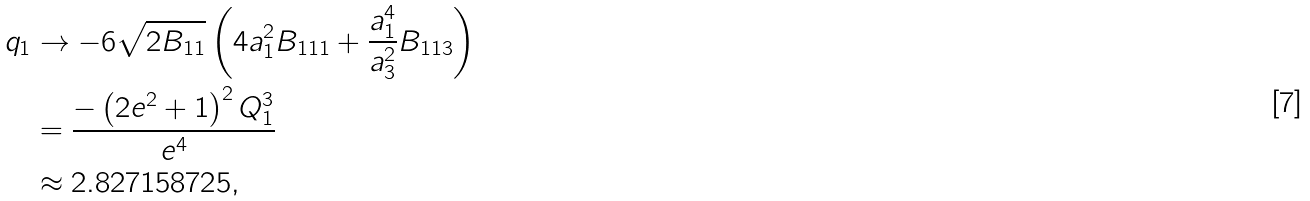<formula> <loc_0><loc_0><loc_500><loc_500>q _ { 1 } & \to - 6 \sqrt { 2 B _ { 1 1 } } \left ( 4 a _ { 1 } ^ { 2 } B _ { 1 1 1 } + \frac { a _ { 1 } ^ { 4 } } { a _ { 3 } ^ { 2 } } B _ { 1 1 3 } \right ) \\ & = \frac { - \left ( 2 e ^ { 2 } + 1 \right ) ^ { 2 } Q _ { 1 } ^ { 3 } } { e ^ { 4 } } \\ & \approx 2 . 8 2 7 1 5 8 7 2 5 ,</formula> 